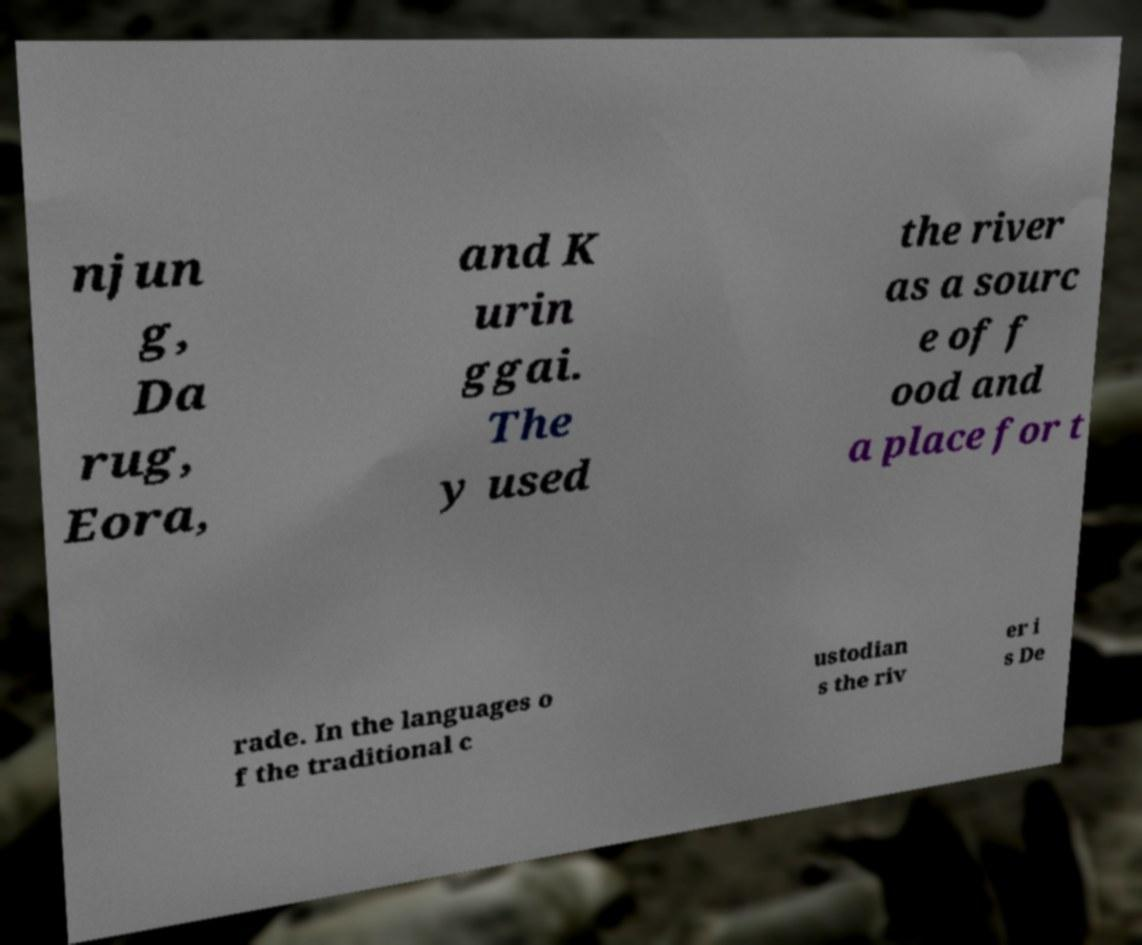What messages or text are displayed in this image? I need them in a readable, typed format. njun g, Da rug, Eora, and K urin ggai. The y used the river as a sourc e of f ood and a place for t rade. In the languages o f the traditional c ustodian s the riv er i s De 